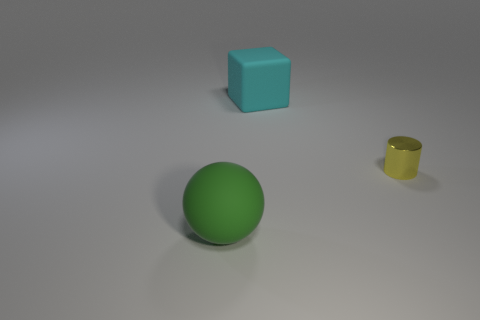Are there fewer big cyan blocks to the left of the large green object than tiny yellow cylinders?
Ensure brevity in your answer.  Yes. How many large cyan metallic cylinders are there?
Provide a short and direct response. 0. There is a big cyan thing; is its shape the same as the matte thing in front of the tiny yellow shiny object?
Your response must be concise. No. Are there fewer yellow shiny cylinders right of the tiny yellow object than large blocks that are in front of the matte ball?
Ensure brevity in your answer.  No. Is there anything else that is the same shape as the green matte thing?
Keep it short and to the point. No. Is there anything else that has the same material as the tiny cylinder?
Ensure brevity in your answer.  No. What size is the yellow cylinder?
Make the answer very short. Small. There is a object that is in front of the big cyan rubber thing and on the left side of the yellow shiny object; what color is it?
Provide a short and direct response. Green. Is the number of yellow things greater than the number of rubber things?
Ensure brevity in your answer.  No. How many objects are yellow rubber balls or things that are behind the cylinder?
Offer a terse response. 1. 